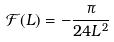Convert formula to latex. <formula><loc_0><loc_0><loc_500><loc_500>\mathcal { F } ( L ) = - \frac { \pi } { 2 4 L ^ { 2 } } \,</formula> 